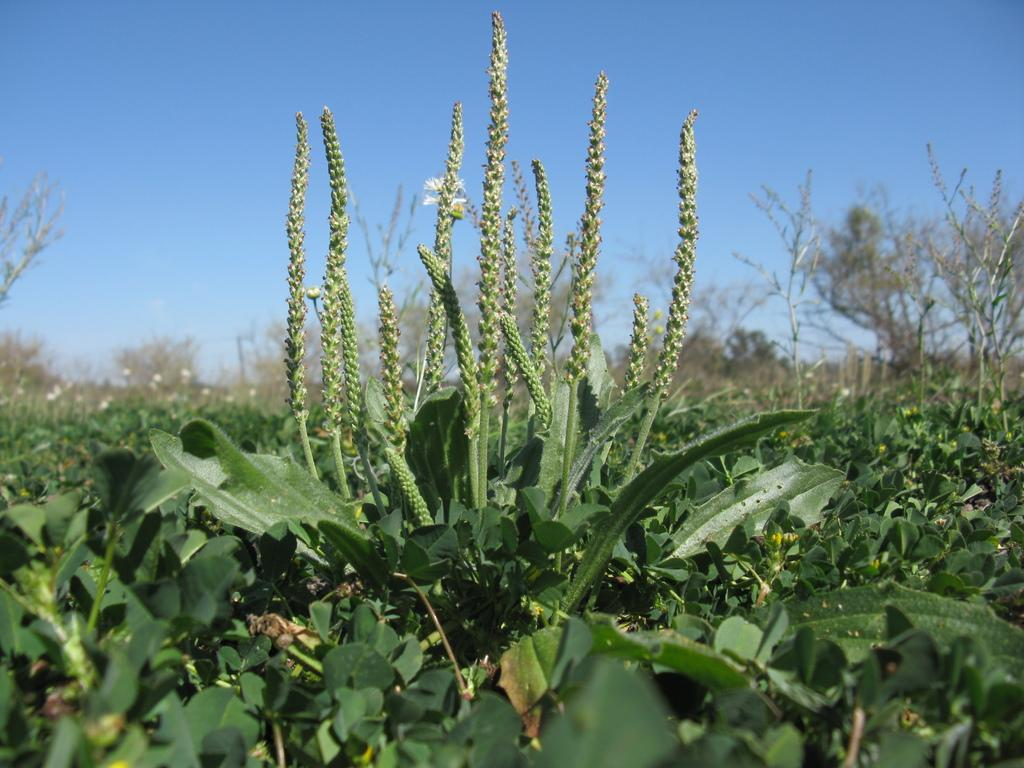What type of living organisms can be seen in the image? Plants can be seen in the image. What is visible at the top of the image? The sky is visible at the top of the image. Can you tell me how many pies are floating in the river in the image? There is no river or pies present in the image; it only features plants and the sky. 